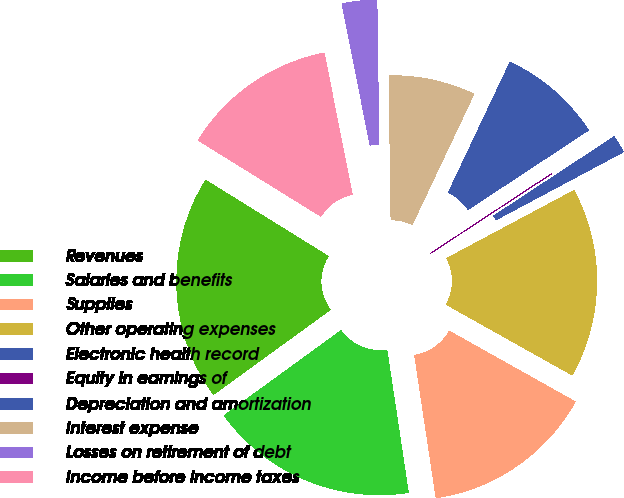<chart> <loc_0><loc_0><loc_500><loc_500><pie_chart><fcel>Revenues<fcel>Salaries and benefits<fcel>Supplies<fcel>Other operating expenses<fcel>Electronic health record<fcel>Equity in earnings of<fcel>Depreciation and amortization<fcel>Interest expense<fcel>Losses on retirement of debt<fcel>Income before income taxes<nl><fcel>18.83%<fcel>17.38%<fcel>14.49%<fcel>15.93%<fcel>1.46%<fcel>0.01%<fcel>8.7%<fcel>7.25%<fcel>2.91%<fcel>13.04%<nl></chart> 